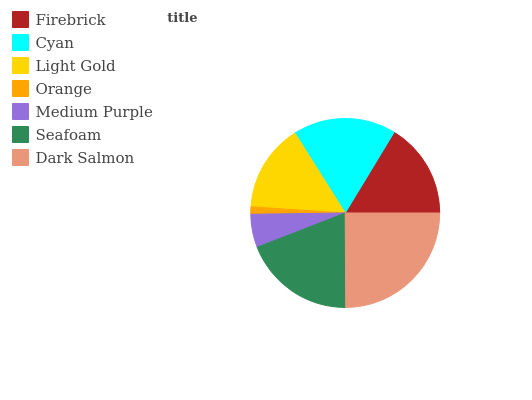Is Orange the minimum?
Answer yes or no. Yes. Is Dark Salmon the maximum?
Answer yes or no. Yes. Is Cyan the minimum?
Answer yes or no. No. Is Cyan the maximum?
Answer yes or no. No. Is Cyan greater than Firebrick?
Answer yes or no. Yes. Is Firebrick less than Cyan?
Answer yes or no. Yes. Is Firebrick greater than Cyan?
Answer yes or no. No. Is Cyan less than Firebrick?
Answer yes or no. No. Is Firebrick the high median?
Answer yes or no. Yes. Is Firebrick the low median?
Answer yes or no. Yes. Is Dark Salmon the high median?
Answer yes or no. No. Is Cyan the low median?
Answer yes or no. No. 